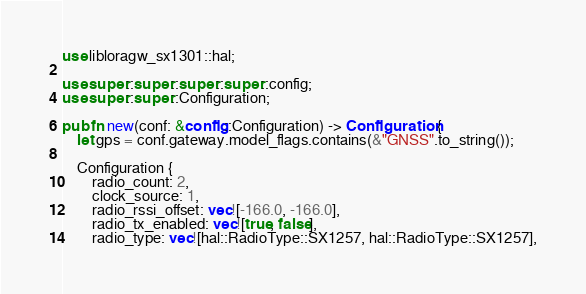<code> <loc_0><loc_0><loc_500><loc_500><_Rust_>use libloragw_sx1301::hal;

use super::super::super::super::config;
use super::super::Configuration;

pub fn new(conf: &config::Configuration) -> Configuration {
    let gps = conf.gateway.model_flags.contains(&"GNSS".to_string());

    Configuration {
        radio_count: 2,
        clock_source: 1,
        radio_rssi_offset: vec![-166.0, -166.0],
        radio_tx_enabled: vec![true, false],
        radio_type: vec![hal::RadioType::SX1257, hal::RadioType::SX1257],</code> 